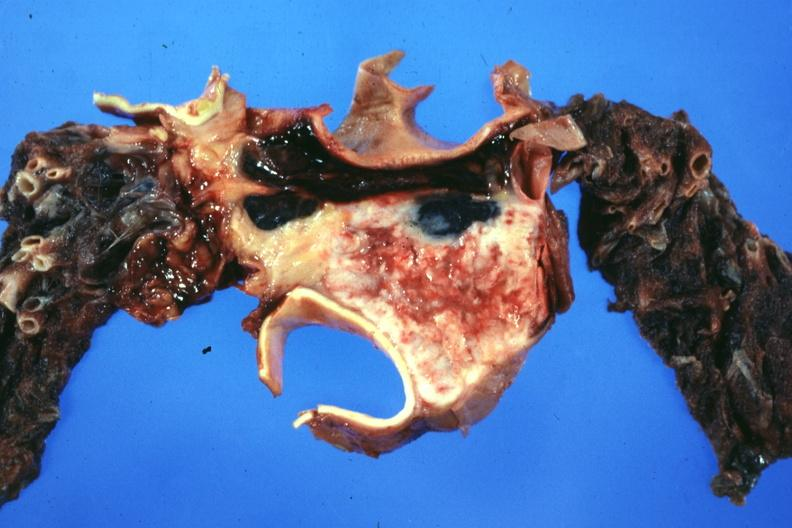what does this image show?
Answer the question using a single word or phrase. Section through mediastinal structure showing tumor about aorta and pulmonary arteries 